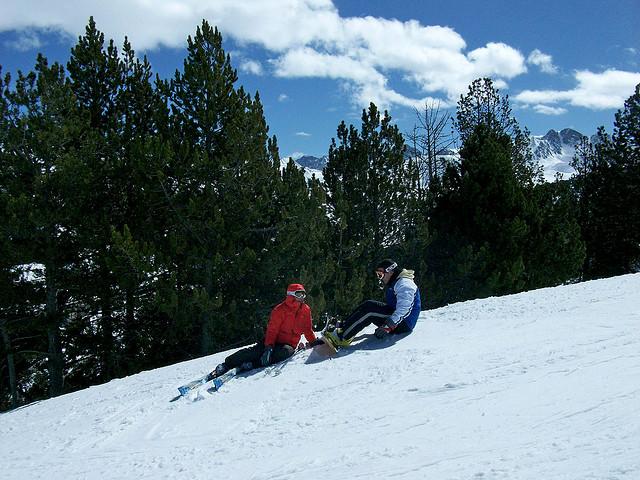What are the two people doing?
Short answer required. Sitting. Do these people know each other?
Quick response, please. Yes. Are they resting?
Answer briefly. Yes. What sport are they doing?
Short answer required. Skiing. 